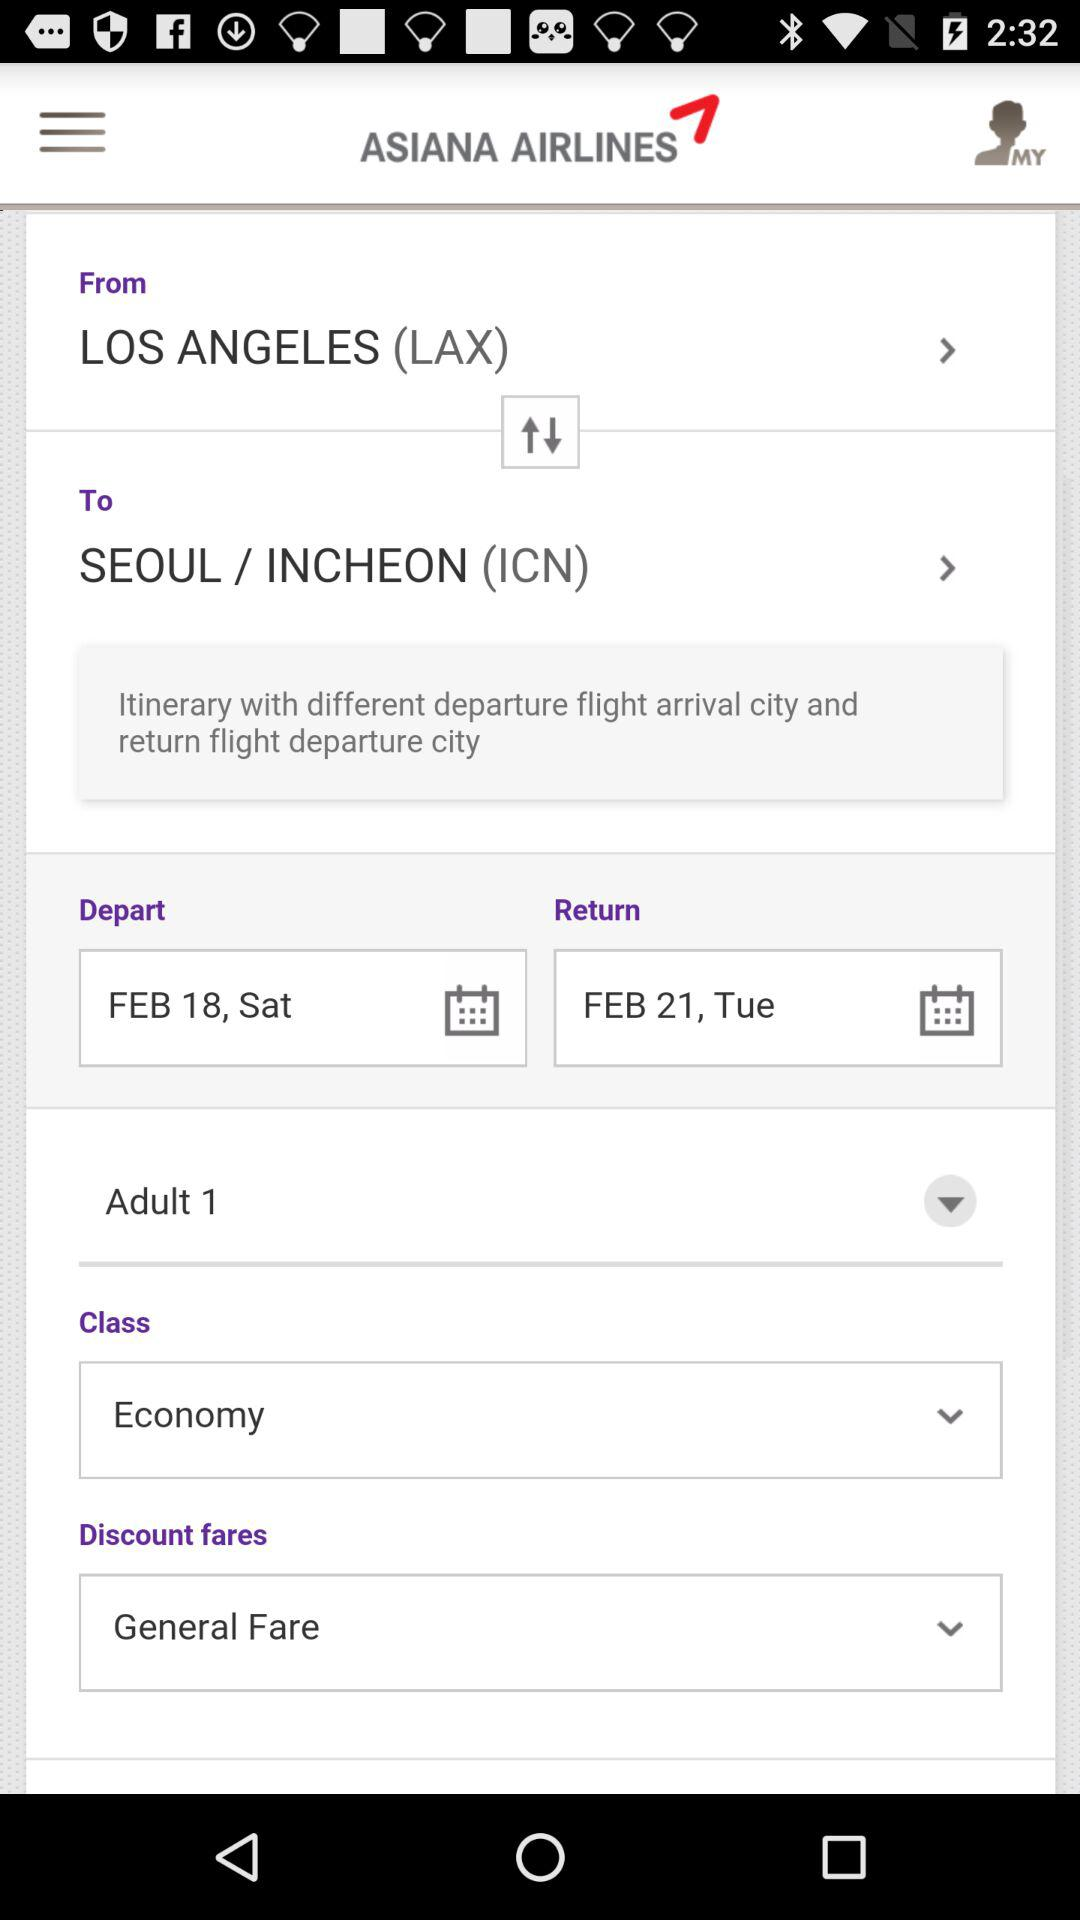What is the starting location? The starting location is "LOS ANGELES". 